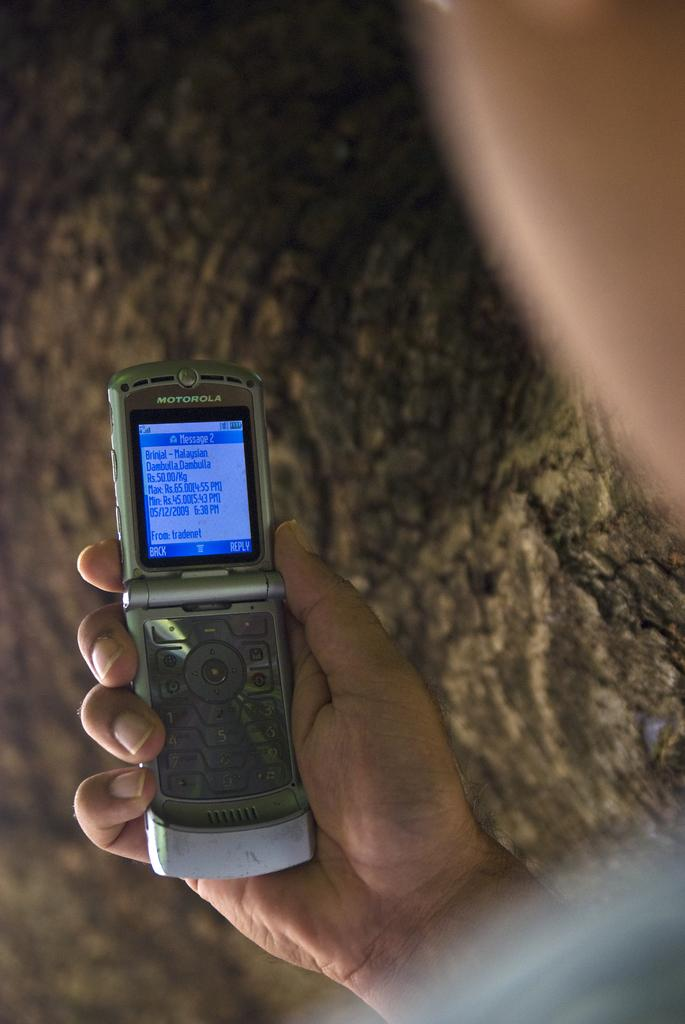<image>
Summarize the visual content of the image. A flip phone with a notification for 2 messages on its screen. 